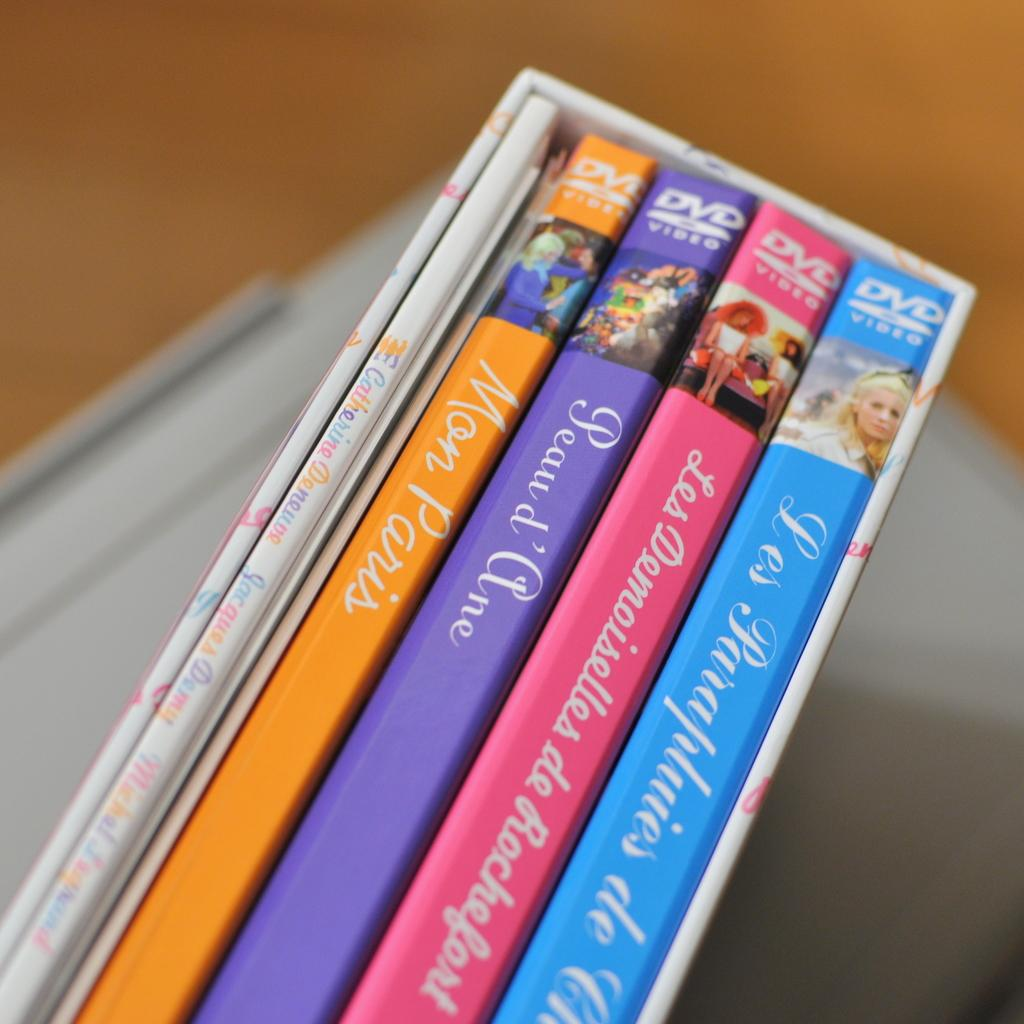Provide a one-sentence caption for the provided image. Four DVD cases are held together in a wooden box along with a small booklet. 